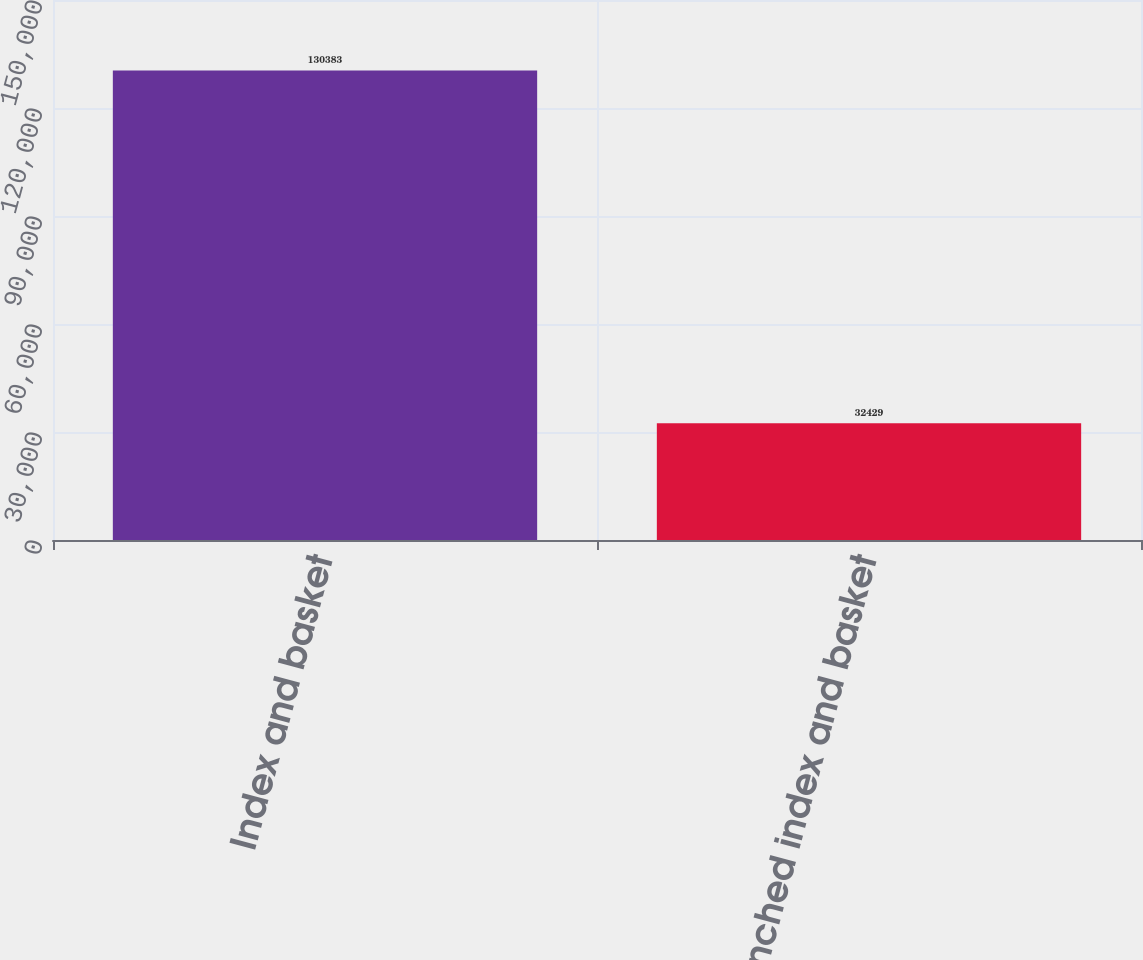<chart> <loc_0><loc_0><loc_500><loc_500><bar_chart><fcel>Index and basket<fcel>Tranched index and basket<nl><fcel>130383<fcel>32429<nl></chart> 